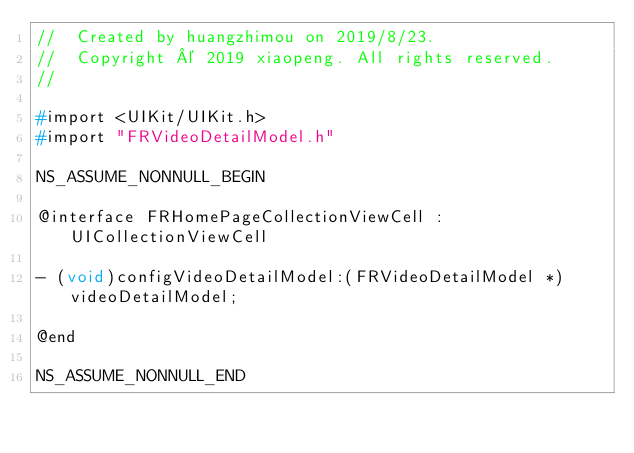<code> <loc_0><loc_0><loc_500><loc_500><_C_>//  Created by huangzhimou on 2019/8/23.
//  Copyright © 2019 xiaopeng. All rights reserved.
//

#import <UIKit/UIKit.h>
#import "FRVideoDetailModel.h"

NS_ASSUME_NONNULL_BEGIN

@interface FRHomePageCollectionViewCell : UICollectionViewCell

- (void)configVideoDetailModel:(FRVideoDetailModel *)videoDetailModel;

@end

NS_ASSUME_NONNULL_END
</code> 